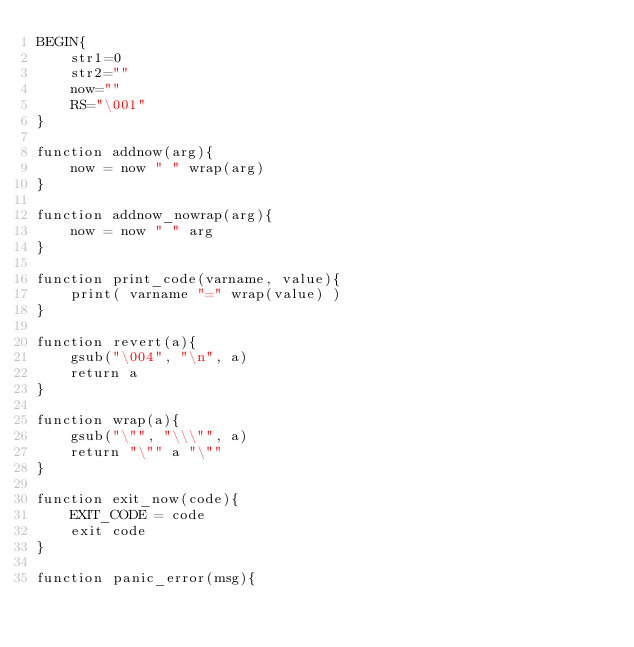<code> <loc_0><loc_0><loc_500><loc_500><_Awk_>BEGIN{
    str1=0
    str2=""
    now=""
    RS="\001"
}

function addnow(arg){
    now = now " " wrap(arg)
}

function addnow_nowrap(arg){
    now = now " " arg
}

function print_code(varname, value){
    print( varname "=" wrap(value) )
}

function revert(a){
    gsub("\004", "\n", a)
    return a
}

function wrap(a){
    gsub("\"", "\\\"", a)
    return "\"" a "\""
}

function exit_now(code){
    EXIT_CODE = code
    exit code
}

function panic_error(msg){</code> 